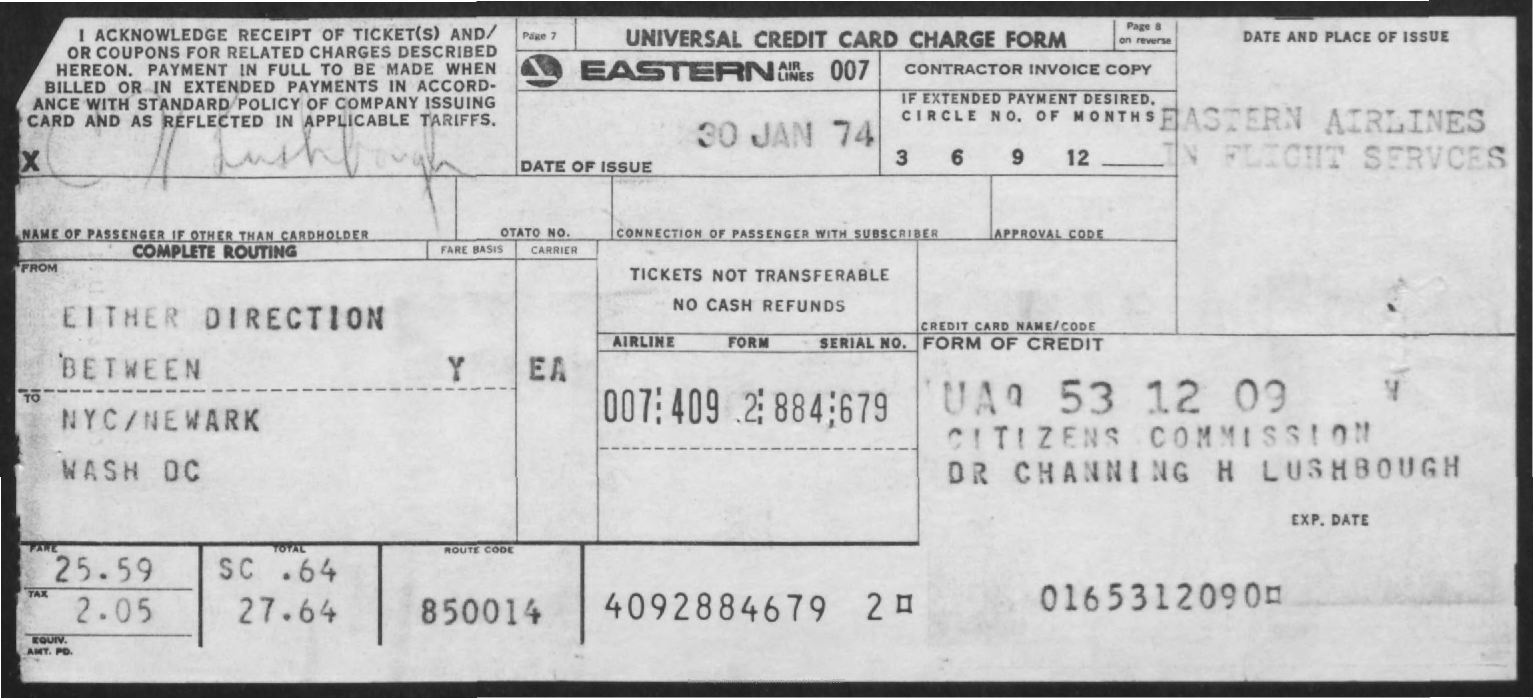What is the name of the form?
Your response must be concise. UNIVERSAL CREDIT CARD CHARGE FORM. On which date was this form issued?
Keep it short and to the point. 30 Jan 74. 